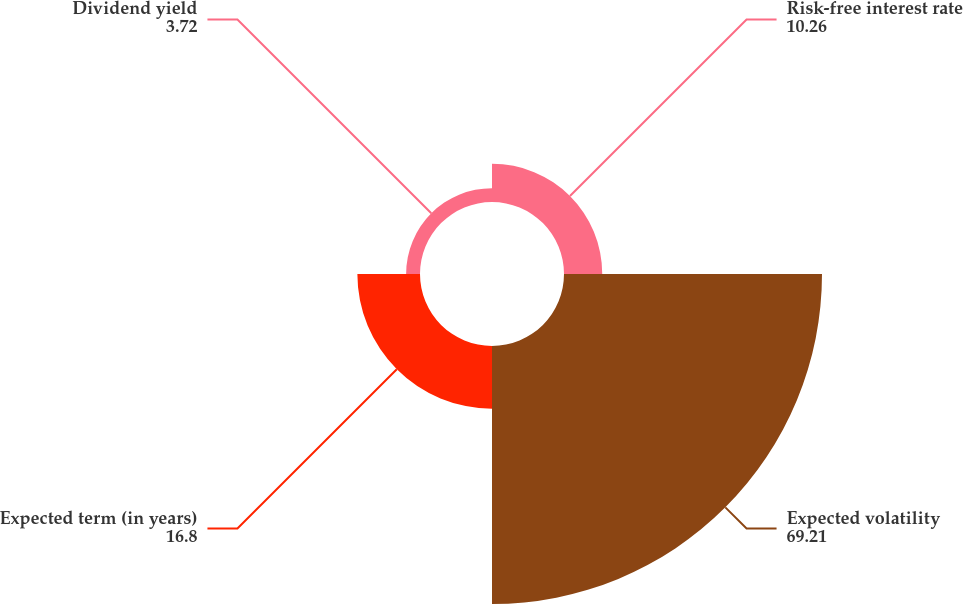<chart> <loc_0><loc_0><loc_500><loc_500><pie_chart><fcel>Risk-free interest rate<fcel>Expected volatility<fcel>Expected term (in years)<fcel>Dividend yield<nl><fcel>10.26%<fcel>69.21%<fcel>16.8%<fcel>3.72%<nl></chart> 